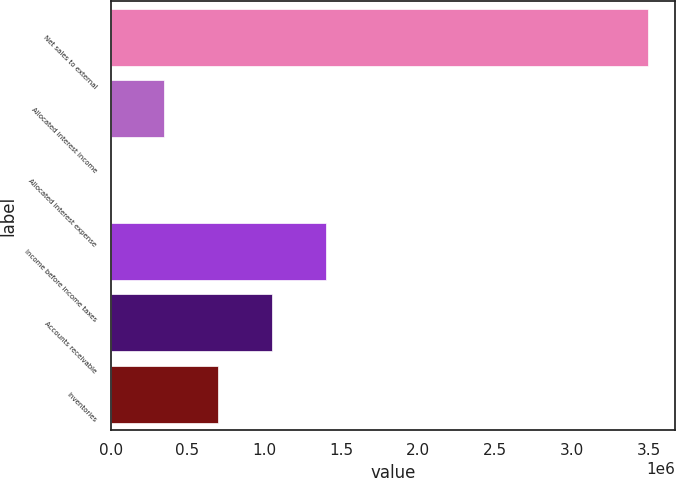Convert chart. <chart><loc_0><loc_0><loc_500><loc_500><bar_chart><fcel>Net sales to external<fcel>Allocated interest income<fcel>Allocated interest expense<fcel>Income before income taxes<fcel>Accounts receivable<fcel>Inventories<nl><fcel>3.49408e+06<fcel>349954<fcel>607<fcel>1.398e+06<fcel>1.04865e+06<fcel>699301<nl></chart> 